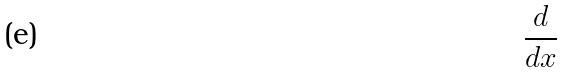Convert formula to latex. <formula><loc_0><loc_0><loc_500><loc_500>\frac { d } { d x }</formula> 